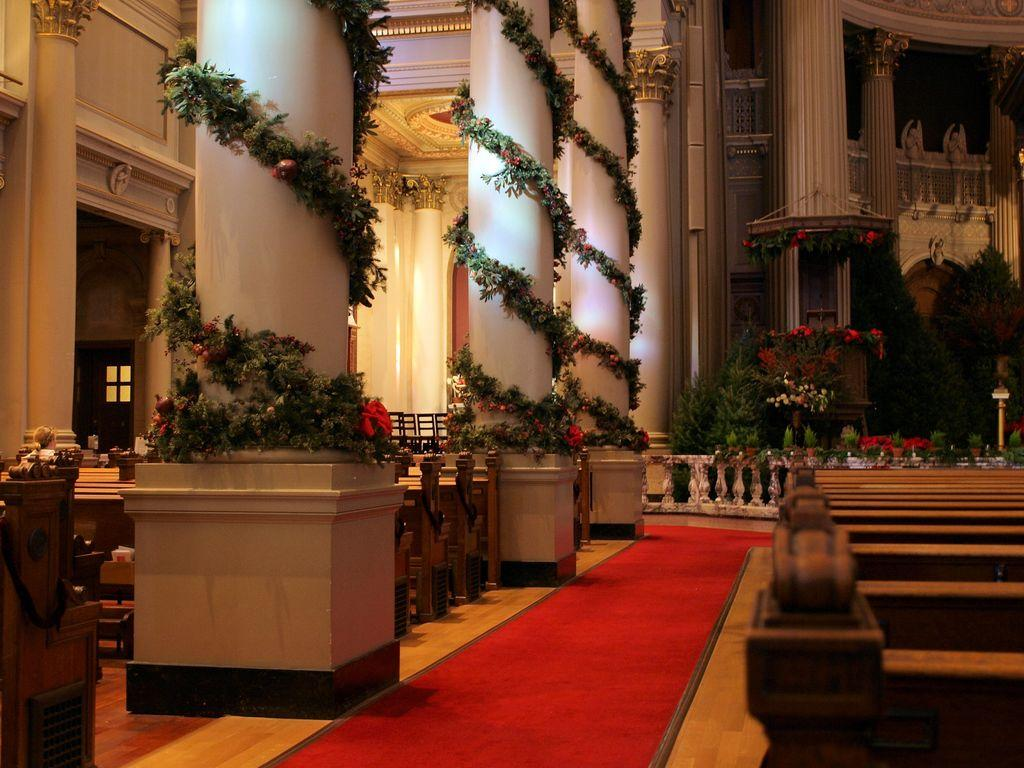What type of architectural feature can be seen in the image? There are pillars in the image. What type of seating is available in the image? There are benches with chairs in the image. How are the walls described in the image? The walls in the image are described as beautiful. What type of vegetation is present in the image? There are plants in the middle of the image. What type of sign can be seen in the image? There is no sign present in the image. What type of straw is used to decorate the benches in the image? There is no straw present in the image; the benches have chairs. 